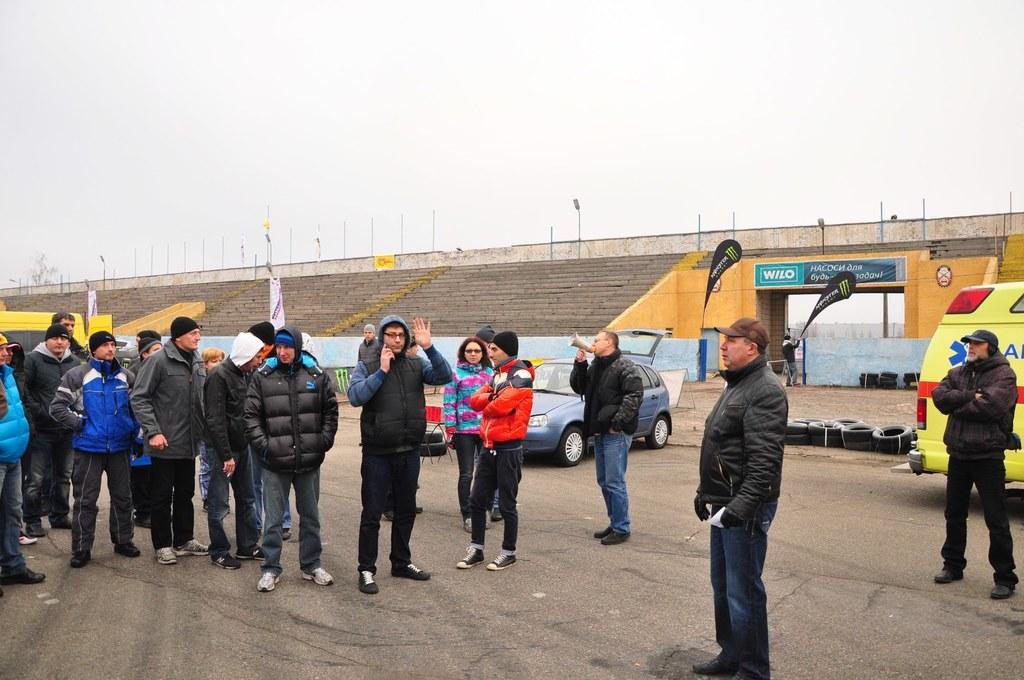Describe this image in one or two sentences. In this image I can see group of people standing. There are vehicles, tyres, boards, poles, lights, stairs and in the background there is sky. 